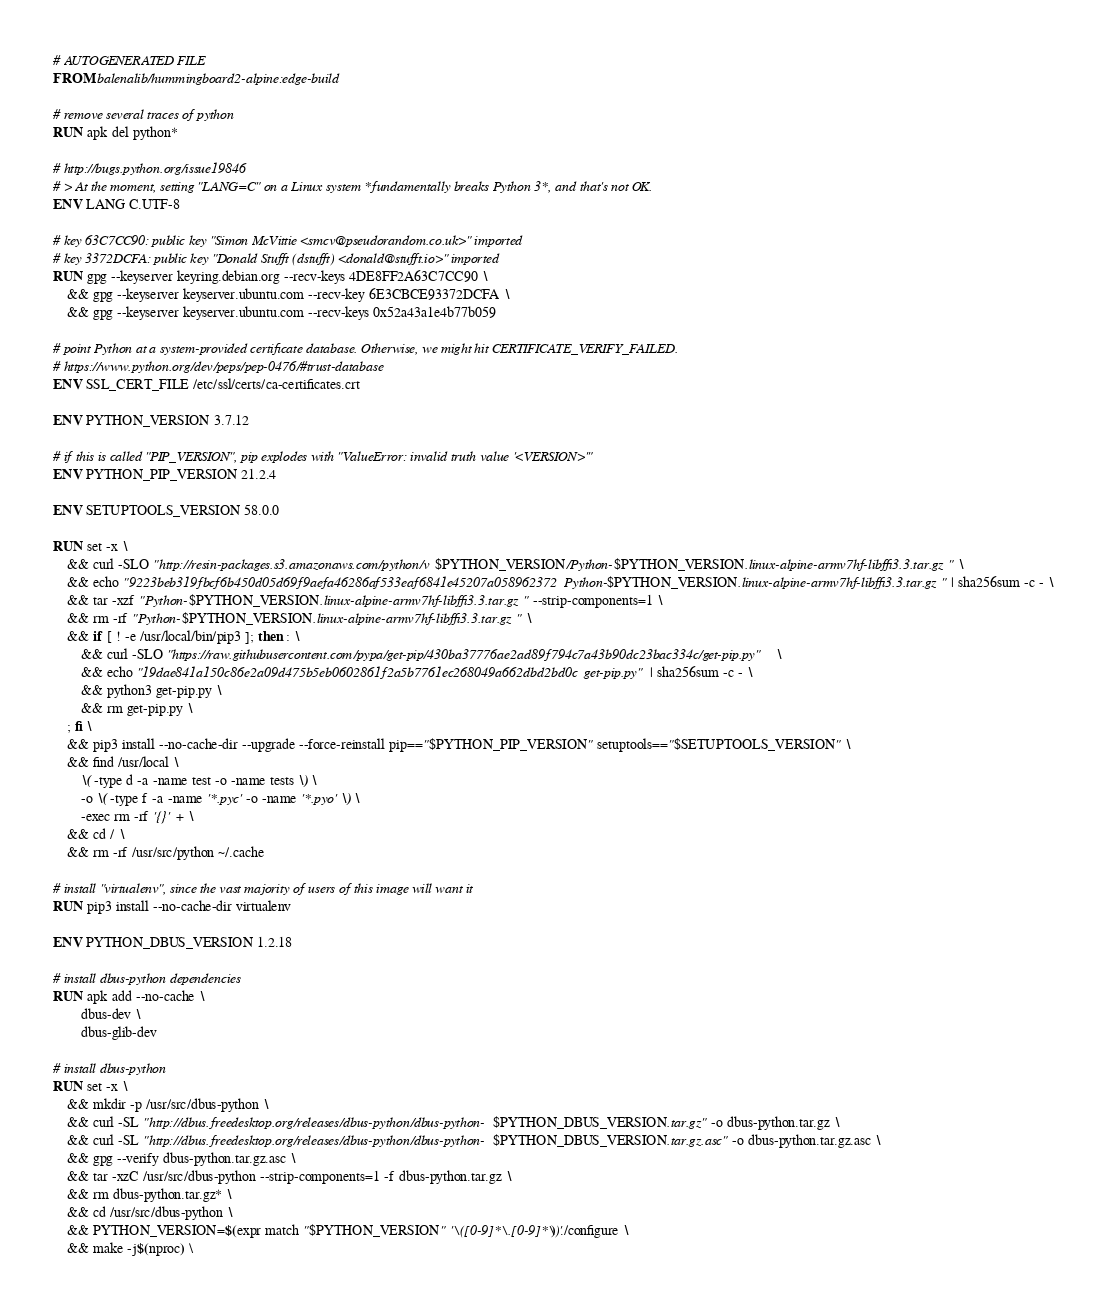Convert code to text. <code><loc_0><loc_0><loc_500><loc_500><_Dockerfile_># AUTOGENERATED FILE
FROM balenalib/hummingboard2-alpine:edge-build

# remove several traces of python
RUN apk del python*

# http://bugs.python.org/issue19846
# > At the moment, setting "LANG=C" on a Linux system *fundamentally breaks Python 3*, and that's not OK.
ENV LANG C.UTF-8

# key 63C7CC90: public key "Simon McVittie <smcv@pseudorandom.co.uk>" imported
# key 3372DCFA: public key "Donald Stufft (dstufft) <donald@stufft.io>" imported
RUN gpg --keyserver keyring.debian.org --recv-keys 4DE8FF2A63C7CC90 \
	&& gpg --keyserver keyserver.ubuntu.com --recv-key 6E3CBCE93372DCFA \
	&& gpg --keyserver keyserver.ubuntu.com --recv-keys 0x52a43a1e4b77b059

# point Python at a system-provided certificate database. Otherwise, we might hit CERTIFICATE_VERIFY_FAILED.
# https://www.python.org/dev/peps/pep-0476/#trust-database
ENV SSL_CERT_FILE /etc/ssl/certs/ca-certificates.crt

ENV PYTHON_VERSION 3.7.12

# if this is called "PIP_VERSION", pip explodes with "ValueError: invalid truth value '<VERSION>'"
ENV PYTHON_PIP_VERSION 21.2.4

ENV SETUPTOOLS_VERSION 58.0.0

RUN set -x \
	&& curl -SLO "http://resin-packages.s3.amazonaws.com/python/v$PYTHON_VERSION/Python-$PYTHON_VERSION.linux-alpine-armv7hf-libffi3.3.tar.gz" \
	&& echo "9223beb319fbcf6b450d05d69f9aefa46286af533eaf6841e45207a058962372  Python-$PYTHON_VERSION.linux-alpine-armv7hf-libffi3.3.tar.gz" | sha256sum -c - \
	&& tar -xzf "Python-$PYTHON_VERSION.linux-alpine-armv7hf-libffi3.3.tar.gz" --strip-components=1 \
	&& rm -rf "Python-$PYTHON_VERSION.linux-alpine-armv7hf-libffi3.3.tar.gz" \
	&& if [ ! -e /usr/local/bin/pip3 ]; then : \
		&& curl -SLO "https://raw.githubusercontent.com/pypa/get-pip/430ba37776ae2ad89f794c7a43b90dc23bac334c/get-pip.py" \
		&& echo "19dae841a150c86e2a09d475b5eb0602861f2a5b7761ec268049a662dbd2bd0c  get-pip.py" | sha256sum -c - \
		&& python3 get-pip.py \
		&& rm get-pip.py \
	; fi \
	&& pip3 install --no-cache-dir --upgrade --force-reinstall pip=="$PYTHON_PIP_VERSION" setuptools=="$SETUPTOOLS_VERSION" \
	&& find /usr/local \
		\( -type d -a -name test -o -name tests \) \
		-o \( -type f -a -name '*.pyc' -o -name '*.pyo' \) \
		-exec rm -rf '{}' + \
	&& cd / \
	&& rm -rf /usr/src/python ~/.cache

# install "virtualenv", since the vast majority of users of this image will want it
RUN pip3 install --no-cache-dir virtualenv

ENV PYTHON_DBUS_VERSION 1.2.18

# install dbus-python dependencies 
RUN apk add --no-cache \
		dbus-dev \
		dbus-glib-dev

# install dbus-python
RUN set -x \
	&& mkdir -p /usr/src/dbus-python \
	&& curl -SL "http://dbus.freedesktop.org/releases/dbus-python/dbus-python-$PYTHON_DBUS_VERSION.tar.gz" -o dbus-python.tar.gz \
	&& curl -SL "http://dbus.freedesktop.org/releases/dbus-python/dbus-python-$PYTHON_DBUS_VERSION.tar.gz.asc" -o dbus-python.tar.gz.asc \
	&& gpg --verify dbus-python.tar.gz.asc \
	&& tar -xzC /usr/src/dbus-python --strip-components=1 -f dbus-python.tar.gz \
	&& rm dbus-python.tar.gz* \
	&& cd /usr/src/dbus-python \
	&& PYTHON_VERSION=$(expr match "$PYTHON_VERSION" '\([0-9]*\.[0-9]*\)') ./configure \
	&& make -j$(nproc) \</code> 